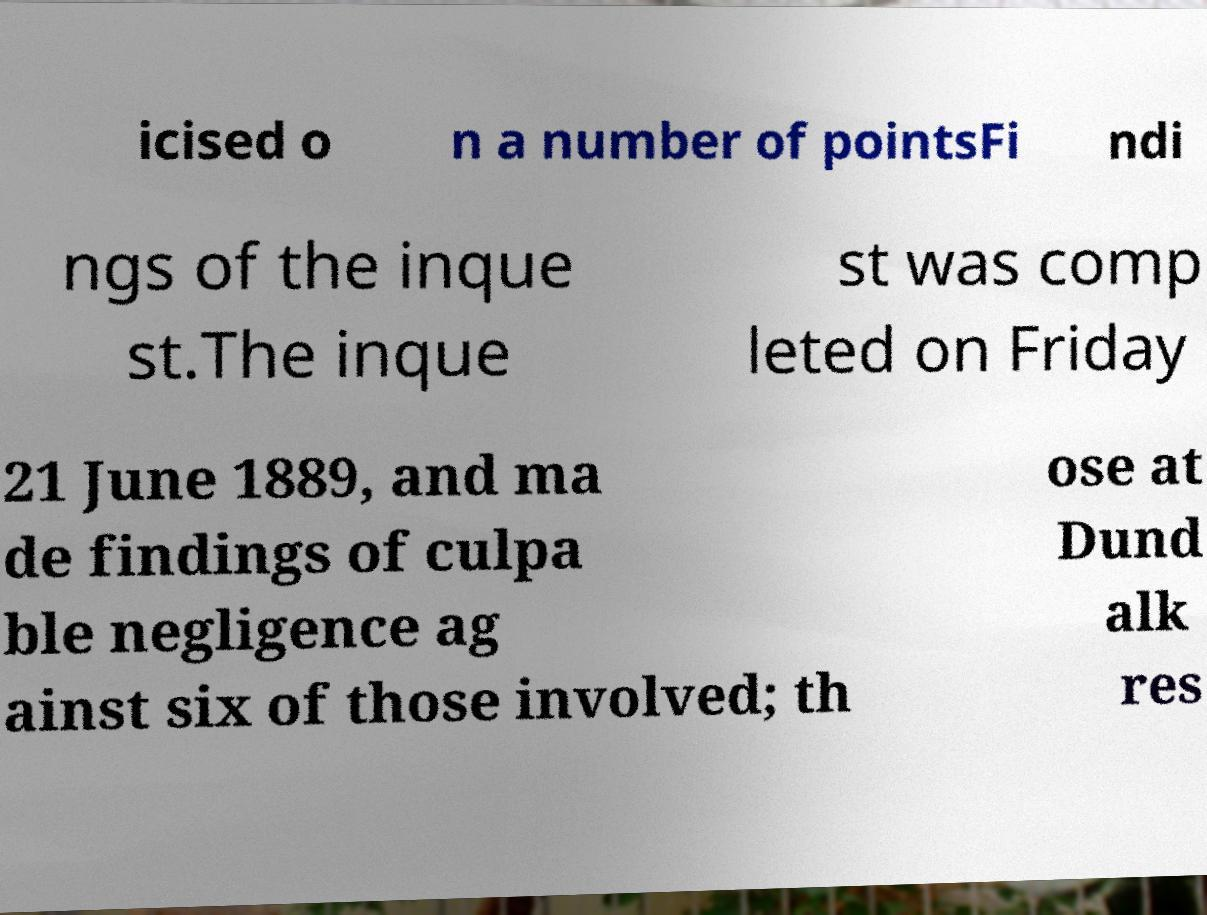I need the written content from this picture converted into text. Can you do that? icised o n a number of pointsFi ndi ngs of the inque st.The inque st was comp leted on Friday 21 June 1889, and ma de findings of culpa ble negligence ag ainst six of those involved; th ose at Dund alk res 